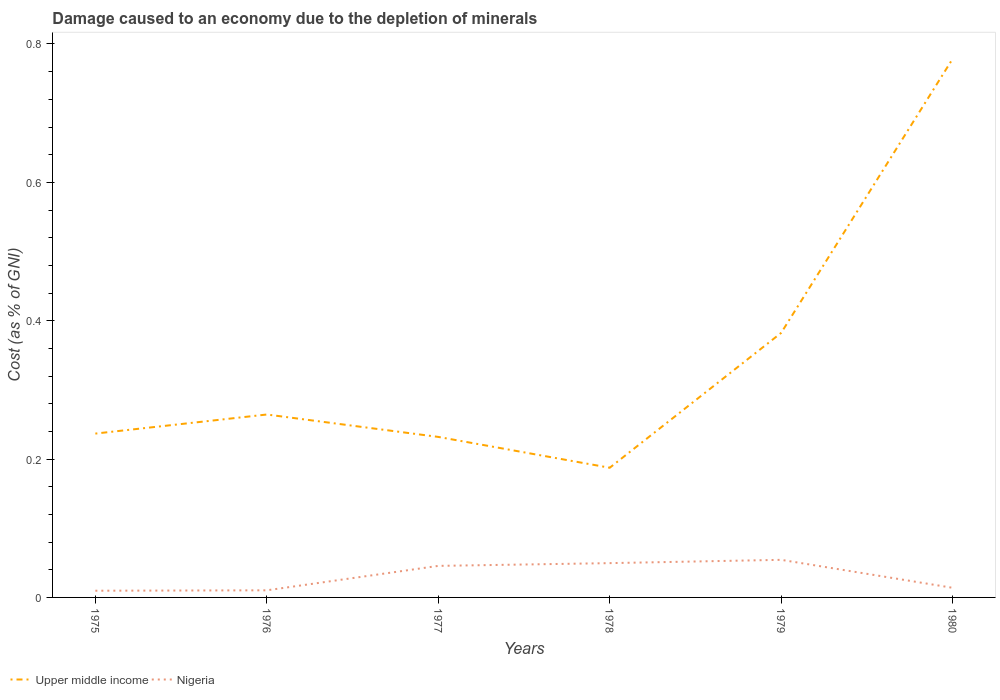How many different coloured lines are there?
Keep it short and to the point. 2. Is the number of lines equal to the number of legend labels?
Offer a terse response. Yes. Across all years, what is the maximum cost of damage caused due to the depletion of minerals in Upper middle income?
Give a very brief answer. 0.19. In which year was the cost of damage caused due to the depletion of minerals in Upper middle income maximum?
Offer a terse response. 1978. What is the total cost of damage caused due to the depletion of minerals in Nigeria in the graph?
Provide a succinct answer. -0.04. What is the difference between the highest and the second highest cost of damage caused due to the depletion of minerals in Nigeria?
Keep it short and to the point. 0.04. What is the difference between the highest and the lowest cost of damage caused due to the depletion of minerals in Nigeria?
Offer a very short reply. 3. Is the cost of damage caused due to the depletion of minerals in Upper middle income strictly greater than the cost of damage caused due to the depletion of minerals in Nigeria over the years?
Provide a succinct answer. No. How many lines are there?
Give a very brief answer. 2. Are the values on the major ticks of Y-axis written in scientific E-notation?
Your answer should be compact. No. Does the graph contain any zero values?
Your answer should be very brief. No. How many legend labels are there?
Keep it short and to the point. 2. How are the legend labels stacked?
Your response must be concise. Horizontal. What is the title of the graph?
Your response must be concise. Damage caused to an economy due to the depletion of minerals. What is the label or title of the Y-axis?
Provide a short and direct response. Cost (as % of GNI). What is the Cost (as % of GNI) of Upper middle income in 1975?
Provide a succinct answer. 0.24. What is the Cost (as % of GNI) of Nigeria in 1975?
Your response must be concise. 0.01. What is the Cost (as % of GNI) in Upper middle income in 1976?
Ensure brevity in your answer.  0.26. What is the Cost (as % of GNI) in Nigeria in 1976?
Provide a succinct answer. 0.01. What is the Cost (as % of GNI) of Upper middle income in 1977?
Keep it short and to the point. 0.23. What is the Cost (as % of GNI) of Nigeria in 1977?
Offer a terse response. 0.05. What is the Cost (as % of GNI) in Upper middle income in 1978?
Give a very brief answer. 0.19. What is the Cost (as % of GNI) in Nigeria in 1978?
Provide a short and direct response. 0.05. What is the Cost (as % of GNI) of Upper middle income in 1979?
Your response must be concise. 0.38. What is the Cost (as % of GNI) in Nigeria in 1979?
Make the answer very short. 0.05. What is the Cost (as % of GNI) of Upper middle income in 1980?
Make the answer very short. 0.78. What is the Cost (as % of GNI) of Nigeria in 1980?
Make the answer very short. 0.01. Across all years, what is the maximum Cost (as % of GNI) of Upper middle income?
Ensure brevity in your answer.  0.78. Across all years, what is the maximum Cost (as % of GNI) in Nigeria?
Make the answer very short. 0.05. Across all years, what is the minimum Cost (as % of GNI) of Upper middle income?
Your answer should be compact. 0.19. Across all years, what is the minimum Cost (as % of GNI) of Nigeria?
Make the answer very short. 0.01. What is the total Cost (as % of GNI) of Upper middle income in the graph?
Keep it short and to the point. 2.08. What is the total Cost (as % of GNI) in Nigeria in the graph?
Provide a succinct answer. 0.18. What is the difference between the Cost (as % of GNI) of Upper middle income in 1975 and that in 1976?
Your response must be concise. -0.03. What is the difference between the Cost (as % of GNI) in Nigeria in 1975 and that in 1976?
Give a very brief answer. -0. What is the difference between the Cost (as % of GNI) in Upper middle income in 1975 and that in 1977?
Provide a short and direct response. 0. What is the difference between the Cost (as % of GNI) of Nigeria in 1975 and that in 1977?
Your response must be concise. -0.04. What is the difference between the Cost (as % of GNI) in Upper middle income in 1975 and that in 1978?
Provide a short and direct response. 0.05. What is the difference between the Cost (as % of GNI) in Nigeria in 1975 and that in 1978?
Provide a succinct answer. -0.04. What is the difference between the Cost (as % of GNI) in Upper middle income in 1975 and that in 1979?
Your answer should be very brief. -0.15. What is the difference between the Cost (as % of GNI) in Nigeria in 1975 and that in 1979?
Give a very brief answer. -0.04. What is the difference between the Cost (as % of GNI) of Upper middle income in 1975 and that in 1980?
Keep it short and to the point. -0.54. What is the difference between the Cost (as % of GNI) in Nigeria in 1975 and that in 1980?
Your answer should be very brief. -0. What is the difference between the Cost (as % of GNI) in Upper middle income in 1976 and that in 1977?
Offer a terse response. 0.03. What is the difference between the Cost (as % of GNI) of Nigeria in 1976 and that in 1977?
Provide a succinct answer. -0.04. What is the difference between the Cost (as % of GNI) in Upper middle income in 1976 and that in 1978?
Offer a terse response. 0.08. What is the difference between the Cost (as % of GNI) in Nigeria in 1976 and that in 1978?
Keep it short and to the point. -0.04. What is the difference between the Cost (as % of GNI) in Upper middle income in 1976 and that in 1979?
Offer a very short reply. -0.12. What is the difference between the Cost (as % of GNI) in Nigeria in 1976 and that in 1979?
Give a very brief answer. -0.04. What is the difference between the Cost (as % of GNI) in Upper middle income in 1976 and that in 1980?
Provide a short and direct response. -0.51. What is the difference between the Cost (as % of GNI) in Nigeria in 1976 and that in 1980?
Offer a very short reply. -0. What is the difference between the Cost (as % of GNI) in Upper middle income in 1977 and that in 1978?
Make the answer very short. 0.04. What is the difference between the Cost (as % of GNI) of Nigeria in 1977 and that in 1978?
Offer a very short reply. -0. What is the difference between the Cost (as % of GNI) in Upper middle income in 1977 and that in 1979?
Give a very brief answer. -0.15. What is the difference between the Cost (as % of GNI) in Nigeria in 1977 and that in 1979?
Offer a terse response. -0.01. What is the difference between the Cost (as % of GNI) in Upper middle income in 1977 and that in 1980?
Ensure brevity in your answer.  -0.55. What is the difference between the Cost (as % of GNI) of Nigeria in 1977 and that in 1980?
Provide a short and direct response. 0.03. What is the difference between the Cost (as % of GNI) in Upper middle income in 1978 and that in 1979?
Your answer should be compact. -0.2. What is the difference between the Cost (as % of GNI) of Nigeria in 1978 and that in 1979?
Give a very brief answer. -0. What is the difference between the Cost (as % of GNI) of Upper middle income in 1978 and that in 1980?
Ensure brevity in your answer.  -0.59. What is the difference between the Cost (as % of GNI) of Nigeria in 1978 and that in 1980?
Your response must be concise. 0.04. What is the difference between the Cost (as % of GNI) in Upper middle income in 1979 and that in 1980?
Ensure brevity in your answer.  -0.4. What is the difference between the Cost (as % of GNI) in Nigeria in 1979 and that in 1980?
Offer a terse response. 0.04. What is the difference between the Cost (as % of GNI) of Upper middle income in 1975 and the Cost (as % of GNI) of Nigeria in 1976?
Ensure brevity in your answer.  0.23. What is the difference between the Cost (as % of GNI) of Upper middle income in 1975 and the Cost (as % of GNI) of Nigeria in 1977?
Make the answer very short. 0.19. What is the difference between the Cost (as % of GNI) in Upper middle income in 1975 and the Cost (as % of GNI) in Nigeria in 1978?
Provide a short and direct response. 0.19. What is the difference between the Cost (as % of GNI) in Upper middle income in 1975 and the Cost (as % of GNI) in Nigeria in 1979?
Ensure brevity in your answer.  0.18. What is the difference between the Cost (as % of GNI) in Upper middle income in 1975 and the Cost (as % of GNI) in Nigeria in 1980?
Provide a succinct answer. 0.22. What is the difference between the Cost (as % of GNI) in Upper middle income in 1976 and the Cost (as % of GNI) in Nigeria in 1977?
Provide a short and direct response. 0.22. What is the difference between the Cost (as % of GNI) of Upper middle income in 1976 and the Cost (as % of GNI) of Nigeria in 1978?
Ensure brevity in your answer.  0.21. What is the difference between the Cost (as % of GNI) of Upper middle income in 1976 and the Cost (as % of GNI) of Nigeria in 1979?
Keep it short and to the point. 0.21. What is the difference between the Cost (as % of GNI) of Upper middle income in 1976 and the Cost (as % of GNI) of Nigeria in 1980?
Offer a very short reply. 0.25. What is the difference between the Cost (as % of GNI) of Upper middle income in 1977 and the Cost (as % of GNI) of Nigeria in 1978?
Keep it short and to the point. 0.18. What is the difference between the Cost (as % of GNI) of Upper middle income in 1977 and the Cost (as % of GNI) of Nigeria in 1979?
Give a very brief answer. 0.18. What is the difference between the Cost (as % of GNI) of Upper middle income in 1977 and the Cost (as % of GNI) of Nigeria in 1980?
Ensure brevity in your answer.  0.22. What is the difference between the Cost (as % of GNI) in Upper middle income in 1978 and the Cost (as % of GNI) in Nigeria in 1979?
Keep it short and to the point. 0.13. What is the difference between the Cost (as % of GNI) of Upper middle income in 1978 and the Cost (as % of GNI) of Nigeria in 1980?
Offer a very short reply. 0.17. What is the difference between the Cost (as % of GNI) in Upper middle income in 1979 and the Cost (as % of GNI) in Nigeria in 1980?
Make the answer very short. 0.37. What is the average Cost (as % of GNI) in Upper middle income per year?
Provide a short and direct response. 0.35. What is the average Cost (as % of GNI) in Nigeria per year?
Your answer should be compact. 0.03. In the year 1975, what is the difference between the Cost (as % of GNI) in Upper middle income and Cost (as % of GNI) in Nigeria?
Keep it short and to the point. 0.23. In the year 1976, what is the difference between the Cost (as % of GNI) of Upper middle income and Cost (as % of GNI) of Nigeria?
Your answer should be very brief. 0.25. In the year 1977, what is the difference between the Cost (as % of GNI) of Upper middle income and Cost (as % of GNI) of Nigeria?
Your answer should be compact. 0.19. In the year 1978, what is the difference between the Cost (as % of GNI) in Upper middle income and Cost (as % of GNI) in Nigeria?
Provide a short and direct response. 0.14. In the year 1979, what is the difference between the Cost (as % of GNI) of Upper middle income and Cost (as % of GNI) of Nigeria?
Provide a short and direct response. 0.33. In the year 1980, what is the difference between the Cost (as % of GNI) in Upper middle income and Cost (as % of GNI) in Nigeria?
Offer a very short reply. 0.76. What is the ratio of the Cost (as % of GNI) of Upper middle income in 1975 to that in 1976?
Your answer should be compact. 0.9. What is the ratio of the Cost (as % of GNI) of Nigeria in 1975 to that in 1976?
Your answer should be compact. 0.94. What is the ratio of the Cost (as % of GNI) in Upper middle income in 1975 to that in 1977?
Offer a terse response. 1.02. What is the ratio of the Cost (as % of GNI) in Nigeria in 1975 to that in 1977?
Make the answer very short. 0.21. What is the ratio of the Cost (as % of GNI) in Upper middle income in 1975 to that in 1978?
Offer a very short reply. 1.26. What is the ratio of the Cost (as % of GNI) in Nigeria in 1975 to that in 1978?
Ensure brevity in your answer.  0.2. What is the ratio of the Cost (as % of GNI) of Upper middle income in 1975 to that in 1979?
Give a very brief answer. 0.62. What is the ratio of the Cost (as % of GNI) in Nigeria in 1975 to that in 1979?
Keep it short and to the point. 0.18. What is the ratio of the Cost (as % of GNI) of Upper middle income in 1975 to that in 1980?
Your answer should be compact. 0.3. What is the ratio of the Cost (as % of GNI) in Nigeria in 1975 to that in 1980?
Your response must be concise. 0.7. What is the ratio of the Cost (as % of GNI) in Upper middle income in 1976 to that in 1977?
Make the answer very short. 1.14. What is the ratio of the Cost (as % of GNI) in Nigeria in 1976 to that in 1977?
Ensure brevity in your answer.  0.23. What is the ratio of the Cost (as % of GNI) of Upper middle income in 1976 to that in 1978?
Keep it short and to the point. 1.41. What is the ratio of the Cost (as % of GNI) in Nigeria in 1976 to that in 1978?
Your answer should be compact. 0.21. What is the ratio of the Cost (as % of GNI) in Upper middle income in 1976 to that in 1979?
Your response must be concise. 0.69. What is the ratio of the Cost (as % of GNI) of Nigeria in 1976 to that in 1979?
Keep it short and to the point. 0.19. What is the ratio of the Cost (as % of GNI) of Upper middle income in 1976 to that in 1980?
Provide a succinct answer. 0.34. What is the ratio of the Cost (as % of GNI) in Nigeria in 1976 to that in 1980?
Offer a terse response. 0.74. What is the ratio of the Cost (as % of GNI) in Upper middle income in 1977 to that in 1978?
Provide a succinct answer. 1.24. What is the ratio of the Cost (as % of GNI) in Nigeria in 1977 to that in 1978?
Keep it short and to the point. 0.92. What is the ratio of the Cost (as % of GNI) of Upper middle income in 1977 to that in 1979?
Keep it short and to the point. 0.61. What is the ratio of the Cost (as % of GNI) of Nigeria in 1977 to that in 1979?
Make the answer very short. 0.84. What is the ratio of the Cost (as % of GNI) in Upper middle income in 1977 to that in 1980?
Make the answer very short. 0.3. What is the ratio of the Cost (as % of GNI) of Nigeria in 1977 to that in 1980?
Give a very brief answer. 3.28. What is the ratio of the Cost (as % of GNI) in Upper middle income in 1978 to that in 1979?
Provide a succinct answer. 0.49. What is the ratio of the Cost (as % of GNI) in Nigeria in 1978 to that in 1979?
Keep it short and to the point. 0.91. What is the ratio of the Cost (as % of GNI) of Upper middle income in 1978 to that in 1980?
Offer a very short reply. 0.24. What is the ratio of the Cost (as % of GNI) in Nigeria in 1978 to that in 1980?
Offer a very short reply. 3.57. What is the ratio of the Cost (as % of GNI) of Upper middle income in 1979 to that in 1980?
Your answer should be very brief. 0.49. What is the ratio of the Cost (as % of GNI) in Nigeria in 1979 to that in 1980?
Keep it short and to the point. 3.91. What is the difference between the highest and the second highest Cost (as % of GNI) of Upper middle income?
Provide a short and direct response. 0.4. What is the difference between the highest and the second highest Cost (as % of GNI) in Nigeria?
Ensure brevity in your answer.  0. What is the difference between the highest and the lowest Cost (as % of GNI) of Upper middle income?
Keep it short and to the point. 0.59. What is the difference between the highest and the lowest Cost (as % of GNI) of Nigeria?
Your response must be concise. 0.04. 